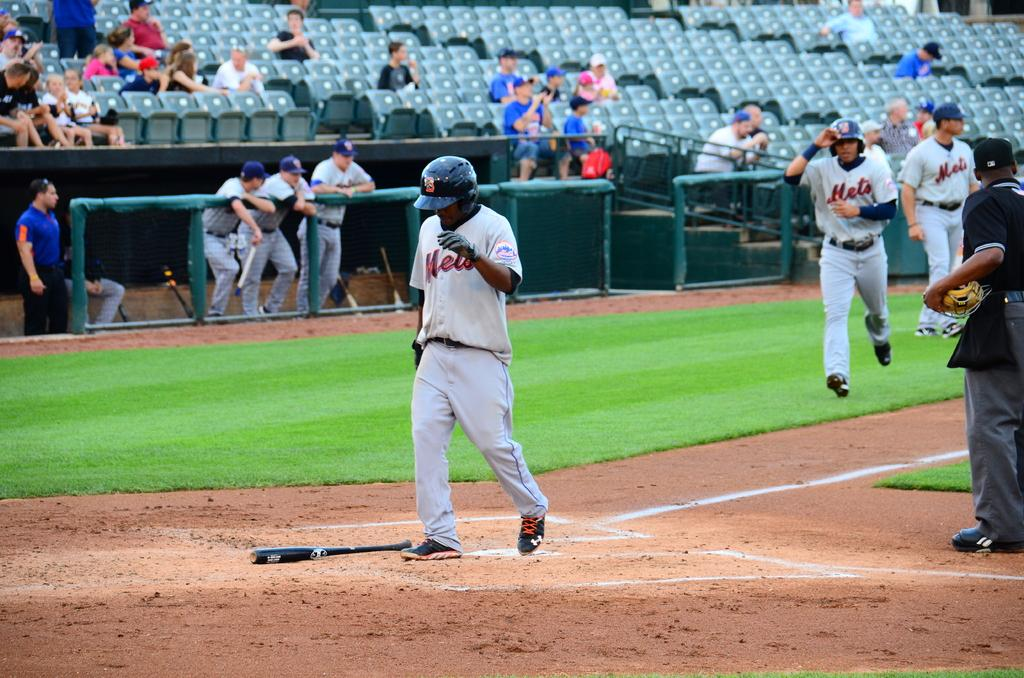<image>
Present a compact description of the photo's key features. A baseball player that plays for the Mets crossing home plate with another runner behind him. 